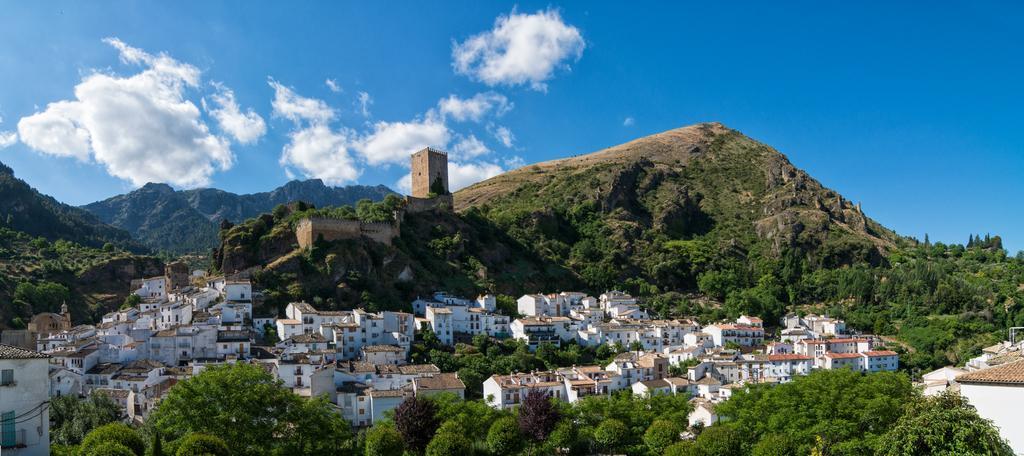Describe this image in one or two sentences. These are the houses and buildings. I can see the trees. This looks like a fort, which is on the hill. I think these are the hills. I can see the clouds in the sky. 